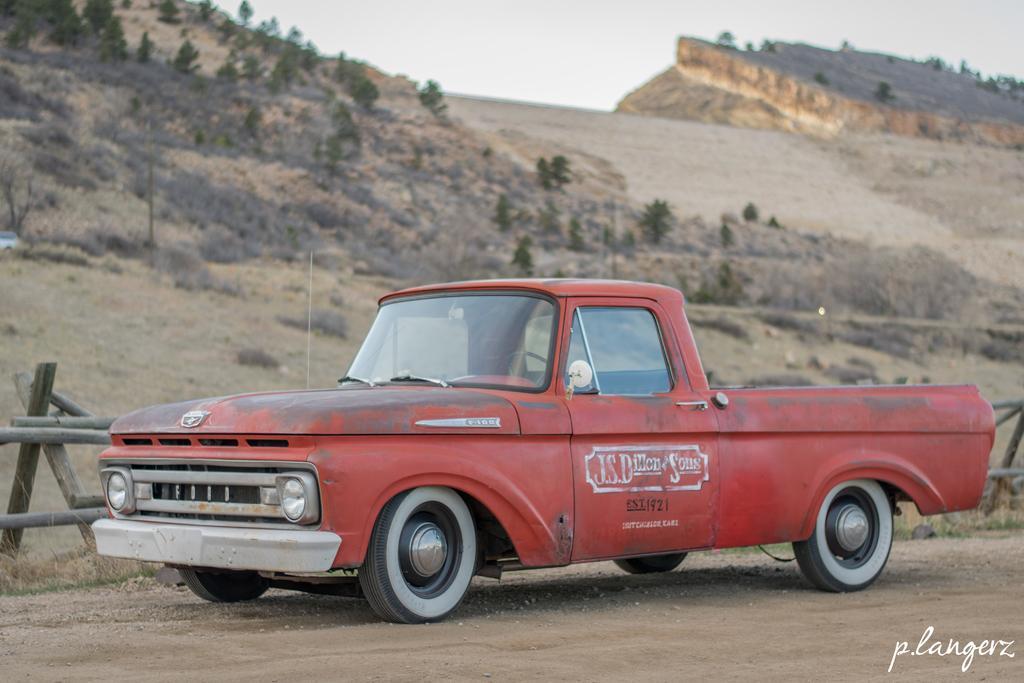Could you give a brief overview of what you see in this image? In this picture there is a red car in the foreground. At the back there is a railing and there are trees on the mountains. At the top there is sky. In the bottom right there is a text. 